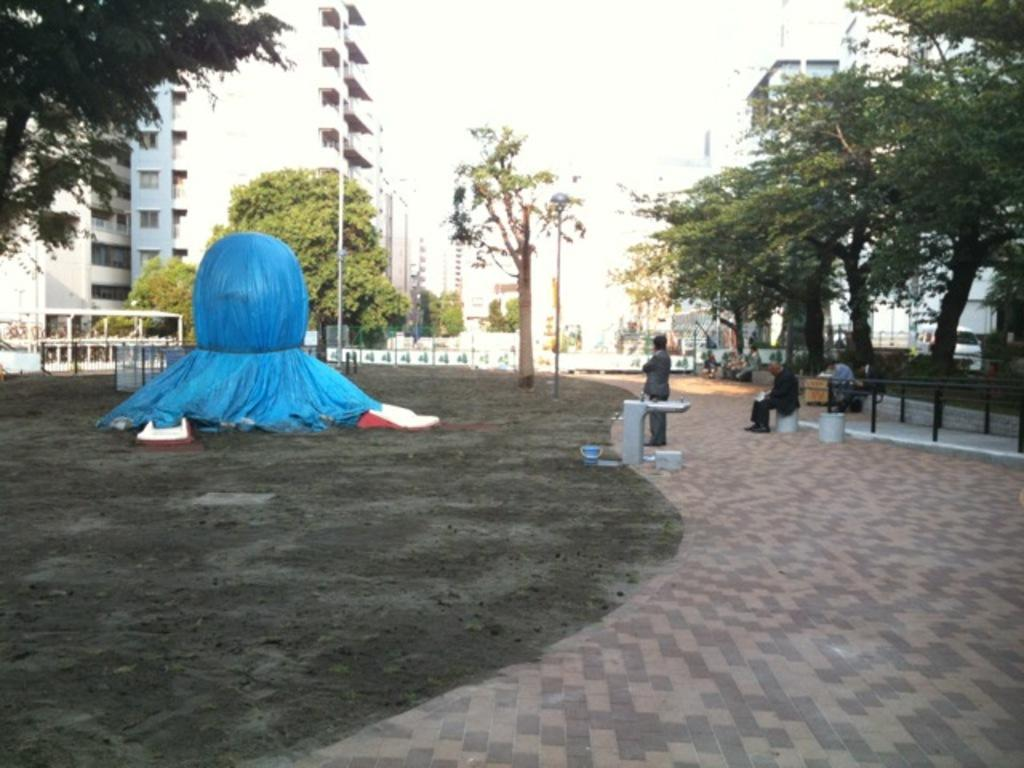What type of structures can be seen in the image? There are buildings in the image. What else can be seen in the image besides buildings? There are trees, people seated, a man standing, a bucket, a blue color cover, and a pole light in the image. What type of pizzas are being served for breakfast in the image? There is no mention of pizzas or breakfast in the image. The image features buildings, trees, people seated, a man standing, a bucket, a blue color cover, and a pole light. 